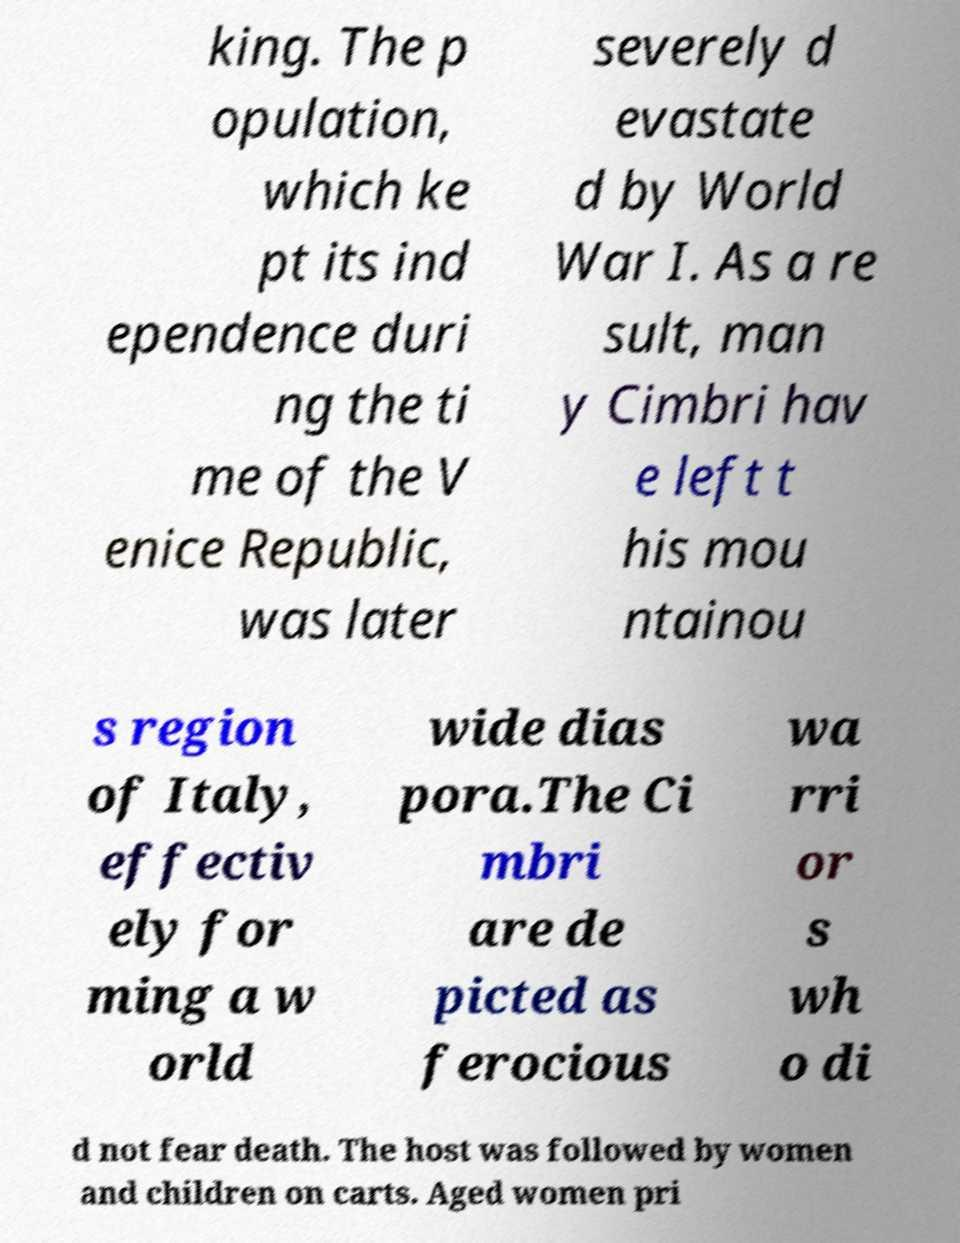Can you read and provide the text displayed in the image?This photo seems to have some interesting text. Can you extract and type it out for me? king. The p opulation, which ke pt its ind ependence duri ng the ti me of the V enice Republic, was later severely d evastate d by World War I. As a re sult, man y Cimbri hav e left t his mou ntainou s region of Italy, effectiv ely for ming a w orld wide dias pora.The Ci mbri are de picted as ferocious wa rri or s wh o di d not fear death. The host was followed by women and children on carts. Aged women pri 